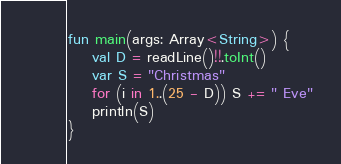Convert code to text. <code><loc_0><loc_0><loc_500><loc_500><_Kotlin_>fun main(args: Array<String>) {
    val D = readLine()!!.toInt()
    var S = "Christmas"
    for (i in 1..(25 - D)) S += " Eve"
    println(S)
}</code> 